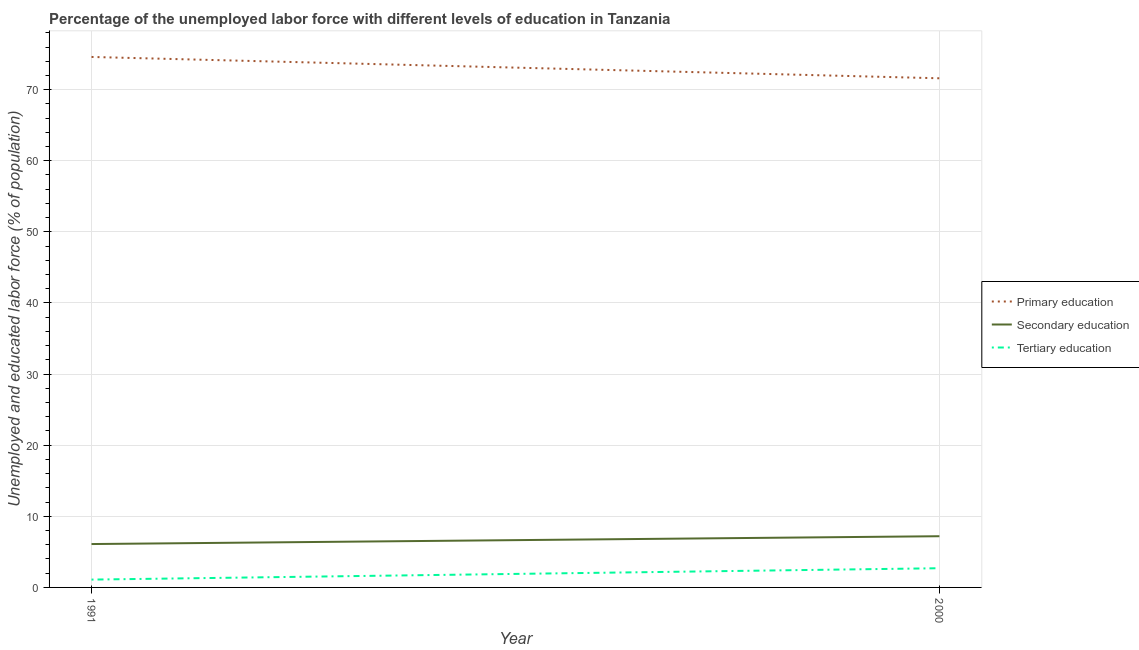Is the number of lines equal to the number of legend labels?
Provide a short and direct response. Yes. What is the percentage of labor force who received secondary education in 2000?
Keep it short and to the point. 7.2. Across all years, what is the maximum percentage of labor force who received tertiary education?
Make the answer very short. 2.7. Across all years, what is the minimum percentage of labor force who received tertiary education?
Provide a short and direct response. 1.1. In which year was the percentage of labor force who received secondary education maximum?
Ensure brevity in your answer.  2000. What is the total percentage of labor force who received primary education in the graph?
Your answer should be compact. 146.2. What is the difference between the percentage of labor force who received tertiary education in 1991 and that in 2000?
Provide a short and direct response. -1.6. What is the difference between the percentage of labor force who received tertiary education in 1991 and the percentage of labor force who received secondary education in 2000?
Offer a terse response. -6.1. What is the average percentage of labor force who received secondary education per year?
Give a very brief answer. 6.65. In the year 1991, what is the difference between the percentage of labor force who received primary education and percentage of labor force who received secondary education?
Provide a short and direct response. 68.5. What is the ratio of the percentage of labor force who received secondary education in 1991 to that in 2000?
Make the answer very short. 0.85. In how many years, is the percentage of labor force who received secondary education greater than the average percentage of labor force who received secondary education taken over all years?
Keep it short and to the point. 1. Is the percentage of labor force who received primary education strictly less than the percentage of labor force who received tertiary education over the years?
Provide a succinct answer. No. What is the difference between two consecutive major ticks on the Y-axis?
Offer a very short reply. 10. Does the graph contain grids?
Ensure brevity in your answer.  Yes. What is the title of the graph?
Your response must be concise. Percentage of the unemployed labor force with different levels of education in Tanzania. Does "Renewable sources" appear as one of the legend labels in the graph?
Keep it short and to the point. No. What is the label or title of the Y-axis?
Provide a succinct answer. Unemployed and educated labor force (% of population). What is the Unemployed and educated labor force (% of population) of Primary education in 1991?
Provide a succinct answer. 74.6. What is the Unemployed and educated labor force (% of population) of Secondary education in 1991?
Keep it short and to the point. 6.1. What is the Unemployed and educated labor force (% of population) in Tertiary education in 1991?
Provide a succinct answer. 1.1. What is the Unemployed and educated labor force (% of population) in Primary education in 2000?
Your answer should be compact. 71.6. What is the Unemployed and educated labor force (% of population) in Secondary education in 2000?
Offer a terse response. 7.2. What is the Unemployed and educated labor force (% of population) in Tertiary education in 2000?
Offer a very short reply. 2.7. Across all years, what is the maximum Unemployed and educated labor force (% of population) of Primary education?
Your answer should be compact. 74.6. Across all years, what is the maximum Unemployed and educated labor force (% of population) of Secondary education?
Make the answer very short. 7.2. Across all years, what is the maximum Unemployed and educated labor force (% of population) in Tertiary education?
Keep it short and to the point. 2.7. Across all years, what is the minimum Unemployed and educated labor force (% of population) in Primary education?
Your response must be concise. 71.6. Across all years, what is the minimum Unemployed and educated labor force (% of population) of Secondary education?
Your answer should be compact. 6.1. Across all years, what is the minimum Unemployed and educated labor force (% of population) of Tertiary education?
Offer a terse response. 1.1. What is the total Unemployed and educated labor force (% of population) of Primary education in the graph?
Give a very brief answer. 146.2. What is the total Unemployed and educated labor force (% of population) of Tertiary education in the graph?
Give a very brief answer. 3.8. What is the difference between the Unemployed and educated labor force (% of population) in Tertiary education in 1991 and that in 2000?
Your response must be concise. -1.6. What is the difference between the Unemployed and educated labor force (% of population) of Primary education in 1991 and the Unemployed and educated labor force (% of population) of Secondary education in 2000?
Offer a terse response. 67.4. What is the difference between the Unemployed and educated labor force (% of population) in Primary education in 1991 and the Unemployed and educated labor force (% of population) in Tertiary education in 2000?
Your response must be concise. 71.9. What is the difference between the Unemployed and educated labor force (% of population) in Secondary education in 1991 and the Unemployed and educated labor force (% of population) in Tertiary education in 2000?
Make the answer very short. 3.4. What is the average Unemployed and educated labor force (% of population) in Primary education per year?
Offer a very short reply. 73.1. What is the average Unemployed and educated labor force (% of population) of Secondary education per year?
Offer a very short reply. 6.65. In the year 1991, what is the difference between the Unemployed and educated labor force (% of population) of Primary education and Unemployed and educated labor force (% of population) of Secondary education?
Provide a short and direct response. 68.5. In the year 1991, what is the difference between the Unemployed and educated labor force (% of population) in Primary education and Unemployed and educated labor force (% of population) in Tertiary education?
Provide a succinct answer. 73.5. In the year 1991, what is the difference between the Unemployed and educated labor force (% of population) in Secondary education and Unemployed and educated labor force (% of population) in Tertiary education?
Your answer should be compact. 5. In the year 2000, what is the difference between the Unemployed and educated labor force (% of population) in Primary education and Unemployed and educated labor force (% of population) in Secondary education?
Provide a succinct answer. 64.4. In the year 2000, what is the difference between the Unemployed and educated labor force (% of population) in Primary education and Unemployed and educated labor force (% of population) in Tertiary education?
Provide a succinct answer. 68.9. In the year 2000, what is the difference between the Unemployed and educated labor force (% of population) in Secondary education and Unemployed and educated labor force (% of population) in Tertiary education?
Offer a terse response. 4.5. What is the ratio of the Unemployed and educated labor force (% of population) of Primary education in 1991 to that in 2000?
Your answer should be very brief. 1.04. What is the ratio of the Unemployed and educated labor force (% of population) of Secondary education in 1991 to that in 2000?
Your response must be concise. 0.85. What is the ratio of the Unemployed and educated labor force (% of population) in Tertiary education in 1991 to that in 2000?
Your answer should be very brief. 0.41. What is the difference between the highest and the second highest Unemployed and educated labor force (% of population) of Primary education?
Ensure brevity in your answer.  3. What is the difference between the highest and the second highest Unemployed and educated labor force (% of population) of Tertiary education?
Your answer should be very brief. 1.6. What is the difference between the highest and the lowest Unemployed and educated labor force (% of population) in Primary education?
Give a very brief answer. 3. 